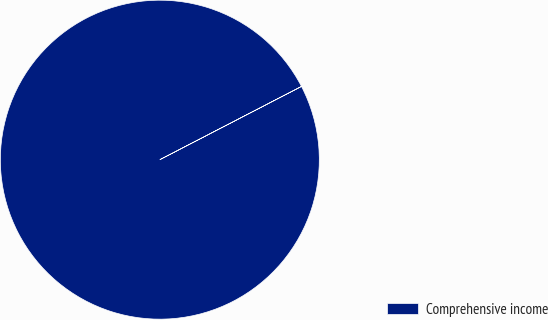Convert chart to OTSL. <chart><loc_0><loc_0><loc_500><loc_500><pie_chart><fcel>Comprehensive income<nl><fcel>100.0%<nl></chart> 